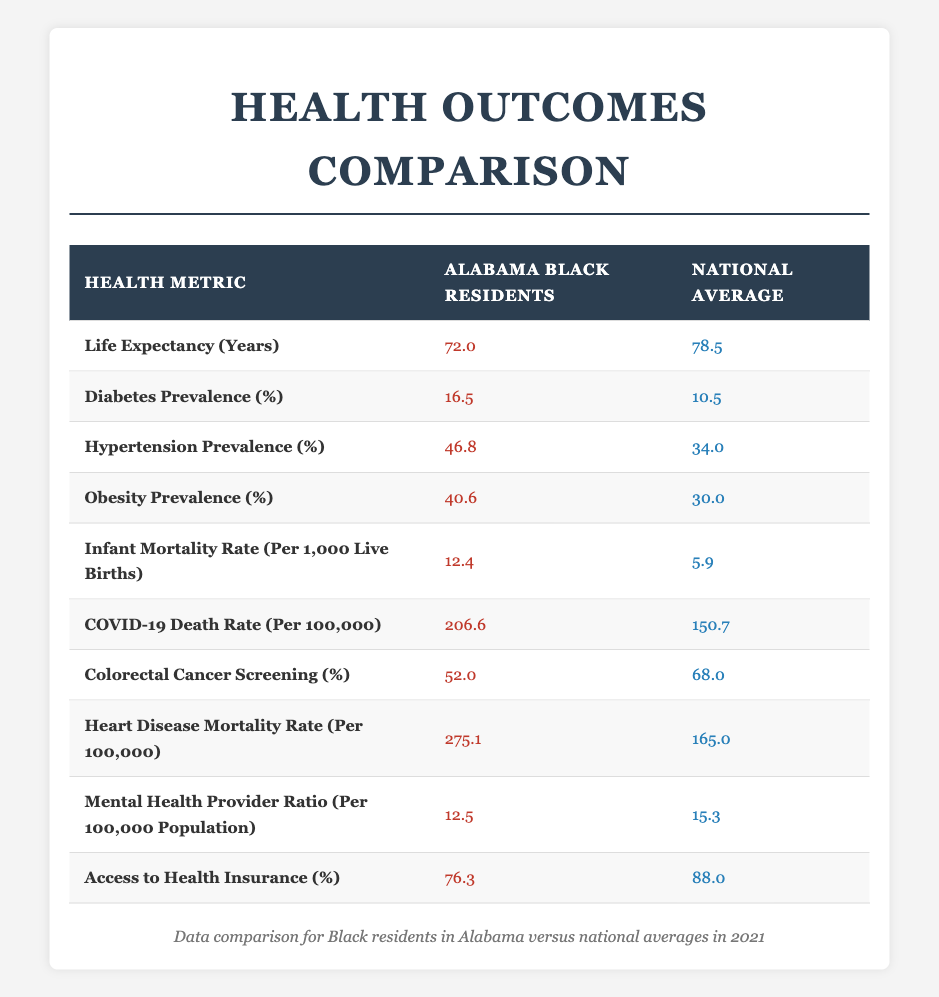What is the life expectancy for Black residents in Alabama? The table lists "Life Expectancy (Years)" for Alabama Black residents as 72.0 years.
Answer: 72.0 years What is the national average for diabetes prevalence? The table shows that the national average for diabetes prevalence is 10.5%.
Answer: 10.5% How much higher is the hypertension prevalence for Black residents in Alabama compared to the national average? The hypertension prevalence for Alabama Black residents is 46.8%, while the national average is 34.0%. The difference is 46.8% - 34.0% = 12.8%.
Answer: 12.8% Is the infant mortality rate for Black residents in Alabama higher than the national average? The table indicates that the infant mortality rate for Alabama Black residents is 12.4 per 1,000 live births, while the national average is 5.9. Since 12.4 is greater than 5.9, the statement is true.
Answer: Yes What is the difference in COVID-19 death rates between Alabama Black residents and the national average? The COVID-19 death rate for Alabama Black residents is 206.6 per 100,000, while the national average is 150.7. The difference is 206.6 - 150.7 = 55.9 per 100,000.
Answer: 55.9 per 100,000 How does the access to health insurance for Black residents in Alabama compare to the national average? Access to health insurance for Alabama Black residents is 76.3%, while the national average is 88.0%. Therefore, Alabama Black residents have less access to health insurance.
Answer: Lower What percentage of Alabama Black residents are obese compared to the national average? Obesity prevalence for Alabama Black residents is 40.6%, and the national average is 30.0%. Thus, Alabama Black residents are 10.6% more obese than the national average (40.6% - 30.0% = 10.6%).
Answer: 10.6% What is the mental health provider ratio difference between Alabama Black residents and the national average? The mental health provider ratio for Alabama Black residents is 12.5 per 100,000, compared to 15.3 for the national average. The difference is 15.3 - 12.5 = 2.8.
Answer: 2.8 per 100,000 Do Black residents in Alabama have a higher heart disease mortality rate than the national average? The heart disease mortality rate for Alabama Black residents is 275.1 per 100,000, while the national average is 165.0. Since 275.1 is greater than 165.0, the answer is yes.
Answer: Yes What is the average life expectancy difference between Black residents in Alabama and the national average? Alabama Black residents have a life expectancy of 72.0 years, while the national average is 78.5 years. The difference is 78.5 - 72.0 = 6.5 years.
Answer: 6.5 years What percentage of Black residents in Alabama participate in colorectal cancer screening compared to the national average? The colorectal cancer screening rate is 52.0% for Alabama Black residents, while the national average is 68.0%. Thus, Alabama Black residents participate 16.0% less than the national average (68.0% - 52.0% = 16.0%).
Answer: 16.0% less 